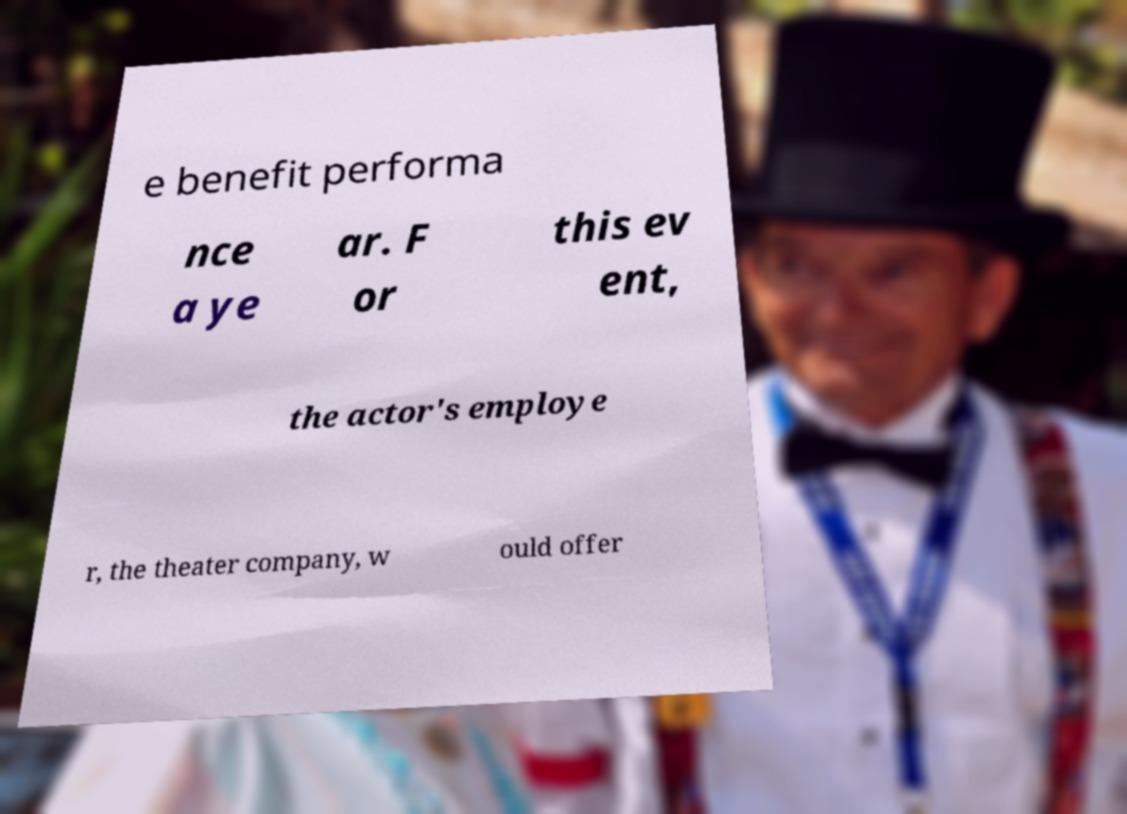Please read and relay the text visible in this image. What does it say? e benefit performa nce a ye ar. F or this ev ent, the actor's employe r, the theater company, w ould offer 